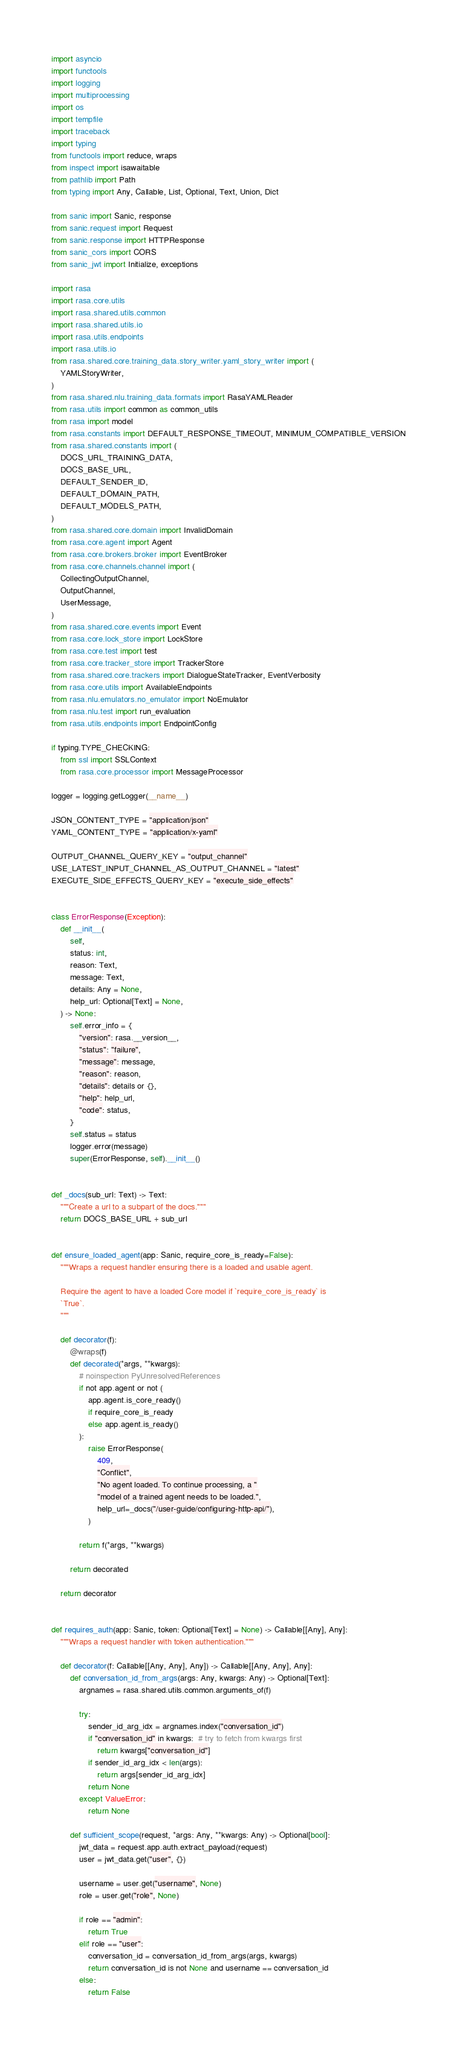<code> <loc_0><loc_0><loc_500><loc_500><_Python_>import asyncio
import functools
import logging
import multiprocessing
import os
import tempfile
import traceback
import typing
from functools import reduce, wraps
from inspect import isawaitable
from pathlib import Path
from typing import Any, Callable, List, Optional, Text, Union, Dict

from sanic import Sanic, response
from sanic.request import Request
from sanic.response import HTTPResponse
from sanic_cors import CORS
from sanic_jwt import Initialize, exceptions

import rasa
import rasa.core.utils
import rasa.shared.utils.common
import rasa.shared.utils.io
import rasa.utils.endpoints
import rasa.utils.io
from rasa.shared.core.training_data.story_writer.yaml_story_writer import (
    YAMLStoryWriter,
)
from rasa.shared.nlu.training_data.formats import RasaYAMLReader
from rasa.utils import common as common_utils
from rasa import model
from rasa.constants import DEFAULT_RESPONSE_TIMEOUT, MINIMUM_COMPATIBLE_VERSION
from rasa.shared.constants import (
    DOCS_URL_TRAINING_DATA,
    DOCS_BASE_URL,
    DEFAULT_SENDER_ID,
    DEFAULT_DOMAIN_PATH,
    DEFAULT_MODELS_PATH,
)
from rasa.shared.core.domain import InvalidDomain
from rasa.core.agent import Agent
from rasa.core.brokers.broker import EventBroker
from rasa.core.channels.channel import (
    CollectingOutputChannel,
    OutputChannel,
    UserMessage,
)
from rasa.shared.core.events import Event
from rasa.core.lock_store import LockStore
from rasa.core.test import test
from rasa.core.tracker_store import TrackerStore
from rasa.shared.core.trackers import DialogueStateTracker, EventVerbosity
from rasa.core.utils import AvailableEndpoints
from rasa.nlu.emulators.no_emulator import NoEmulator
from rasa.nlu.test import run_evaluation
from rasa.utils.endpoints import EndpointConfig

if typing.TYPE_CHECKING:
    from ssl import SSLContext
    from rasa.core.processor import MessageProcessor

logger = logging.getLogger(__name__)

JSON_CONTENT_TYPE = "application/json"
YAML_CONTENT_TYPE = "application/x-yaml"

OUTPUT_CHANNEL_QUERY_KEY = "output_channel"
USE_LATEST_INPUT_CHANNEL_AS_OUTPUT_CHANNEL = "latest"
EXECUTE_SIDE_EFFECTS_QUERY_KEY = "execute_side_effects"


class ErrorResponse(Exception):
    def __init__(
        self,
        status: int,
        reason: Text,
        message: Text,
        details: Any = None,
        help_url: Optional[Text] = None,
    ) -> None:
        self.error_info = {
            "version": rasa.__version__,
            "status": "failure",
            "message": message,
            "reason": reason,
            "details": details or {},
            "help": help_url,
            "code": status,
        }
        self.status = status
        logger.error(message)
        super(ErrorResponse, self).__init__()


def _docs(sub_url: Text) -> Text:
    """Create a url to a subpart of the docs."""
    return DOCS_BASE_URL + sub_url


def ensure_loaded_agent(app: Sanic, require_core_is_ready=False):
    """Wraps a request handler ensuring there is a loaded and usable agent.

    Require the agent to have a loaded Core model if `require_core_is_ready` is
    `True`.
    """

    def decorator(f):
        @wraps(f)
        def decorated(*args, **kwargs):
            # noinspection PyUnresolvedReferences
            if not app.agent or not (
                app.agent.is_core_ready()
                if require_core_is_ready
                else app.agent.is_ready()
            ):
                raise ErrorResponse(
                    409,
                    "Conflict",
                    "No agent loaded. To continue processing, a "
                    "model of a trained agent needs to be loaded.",
                    help_url=_docs("/user-guide/configuring-http-api/"),
                )

            return f(*args, **kwargs)

        return decorated

    return decorator


def requires_auth(app: Sanic, token: Optional[Text] = None) -> Callable[[Any], Any]:
    """Wraps a request handler with token authentication."""

    def decorator(f: Callable[[Any, Any], Any]) -> Callable[[Any, Any], Any]:
        def conversation_id_from_args(args: Any, kwargs: Any) -> Optional[Text]:
            argnames = rasa.shared.utils.common.arguments_of(f)

            try:
                sender_id_arg_idx = argnames.index("conversation_id")
                if "conversation_id" in kwargs:  # try to fetch from kwargs first
                    return kwargs["conversation_id"]
                if sender_id_arg_idx < len(args):
                    return args[sender_id_arg_idx]
                return None
            except ValueError:
                return None

        def sufficient_scope(request, *args: Any, **kwargs: Any) -> Optional[bool]:
            jwt_data = request.app.auth.extract_payload(request)
            user = jwt_data.get("user", {})

            username = user.get("username", None)
            role = user.get("role", None)

            if role == "admin":
                return True
            elif role == "user":
                conversation_id = conversation_id_from_args(args, kwargs)
                return conversation_id is not None and username == conversation_id
            else:
                return False
</code> 